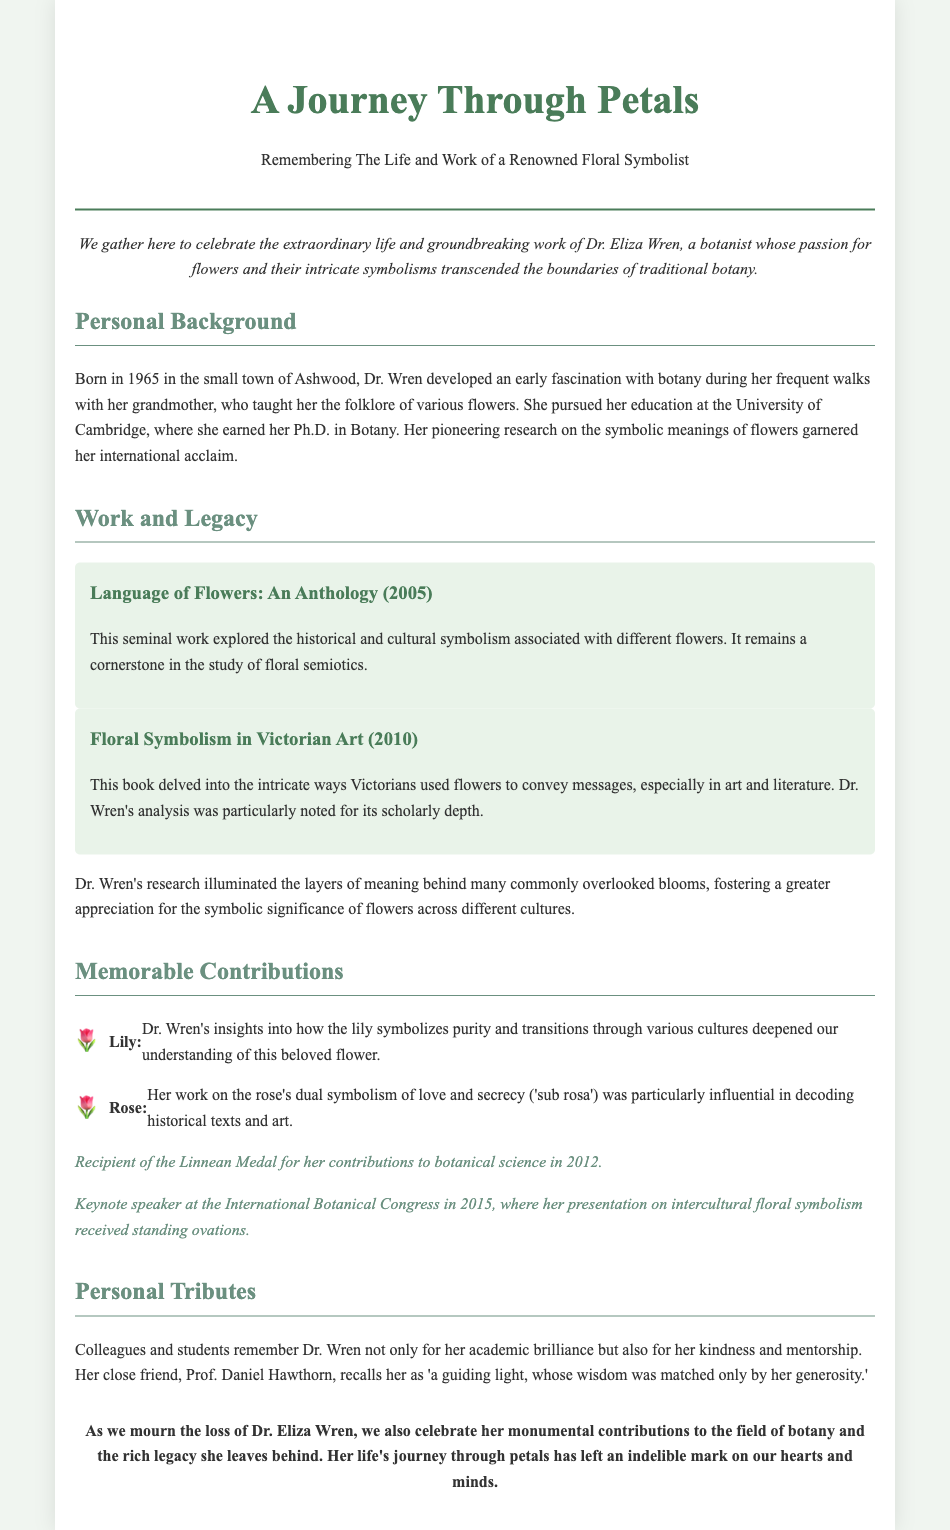What year was Dr. Eliza Wren born? The document states that Dr. Wren was born in 1965.
Answer: 1965 What is the title of Dr. Wren's seminal work published in 2005? The document lists "Language of Flowers: An Anthology" as her seminal work published in 2005.
Answer: Language of Flowers: An Anthology Which flower symbolizes purity according to Dr. Wren's insights? The document mentions that the lily symbolizes purity.
Answer: Lily What prestigious award did Dr. Wren receive in 2012? The document states that Dr. Wren was awarded the Linnean Medal in 2012.
Answer: Linnean Medal Who described Dr. Wren as "a guiding light"? The document quotes her close friend, Prof. Daniel Hawthorn, who referred to her as "a guiding light."
Answer: Prof. Daniel Hawthorn What significant event took place in 2015 related to Dr. Wren? The document notes that she was a keynote speaker at the International Botanical Congress in 2015.
Answer: Keynote speaker at the International Botanical Congress In which small town was Dr. Wren born? The document reveals that she was born in Ashwood.
Answer: Ashwood What was Dr. Wren's field of study? The document states that her field of study was Botany.
Answer: Botany 